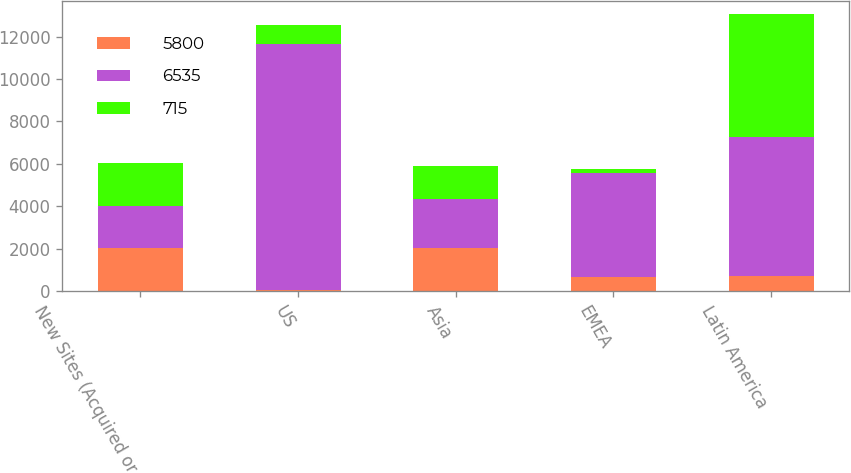Convert chart. <chart><loc_0><loc_0><loc_500><loc_500><stacked_bar_chart><ecel><fcel>New Sites (Acquired or<fcel>US<fcel>Asia<fcel>EMEA<fcel>Latin America<nl><fcel>5800<fcel>2016<fcel>65<fcel>2014.5<fcel>665<fcel>715<nl><fcel>6535<fcel>2015<fcel>11595<fcel>2330<fcel>4910<fcel>6535<nl><fcel>715<fcel>2014<fcel>900<fcel>1560<fcel>190<fcel>5800<nl></chart> 